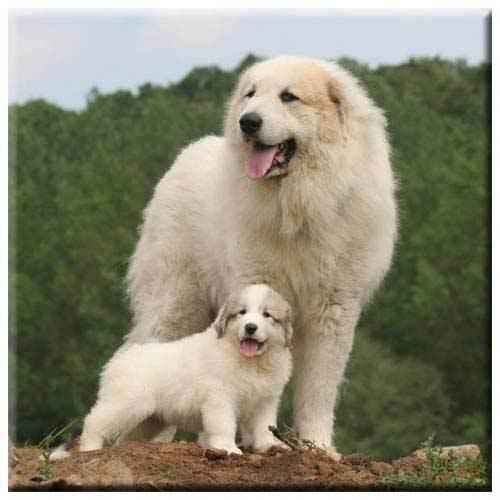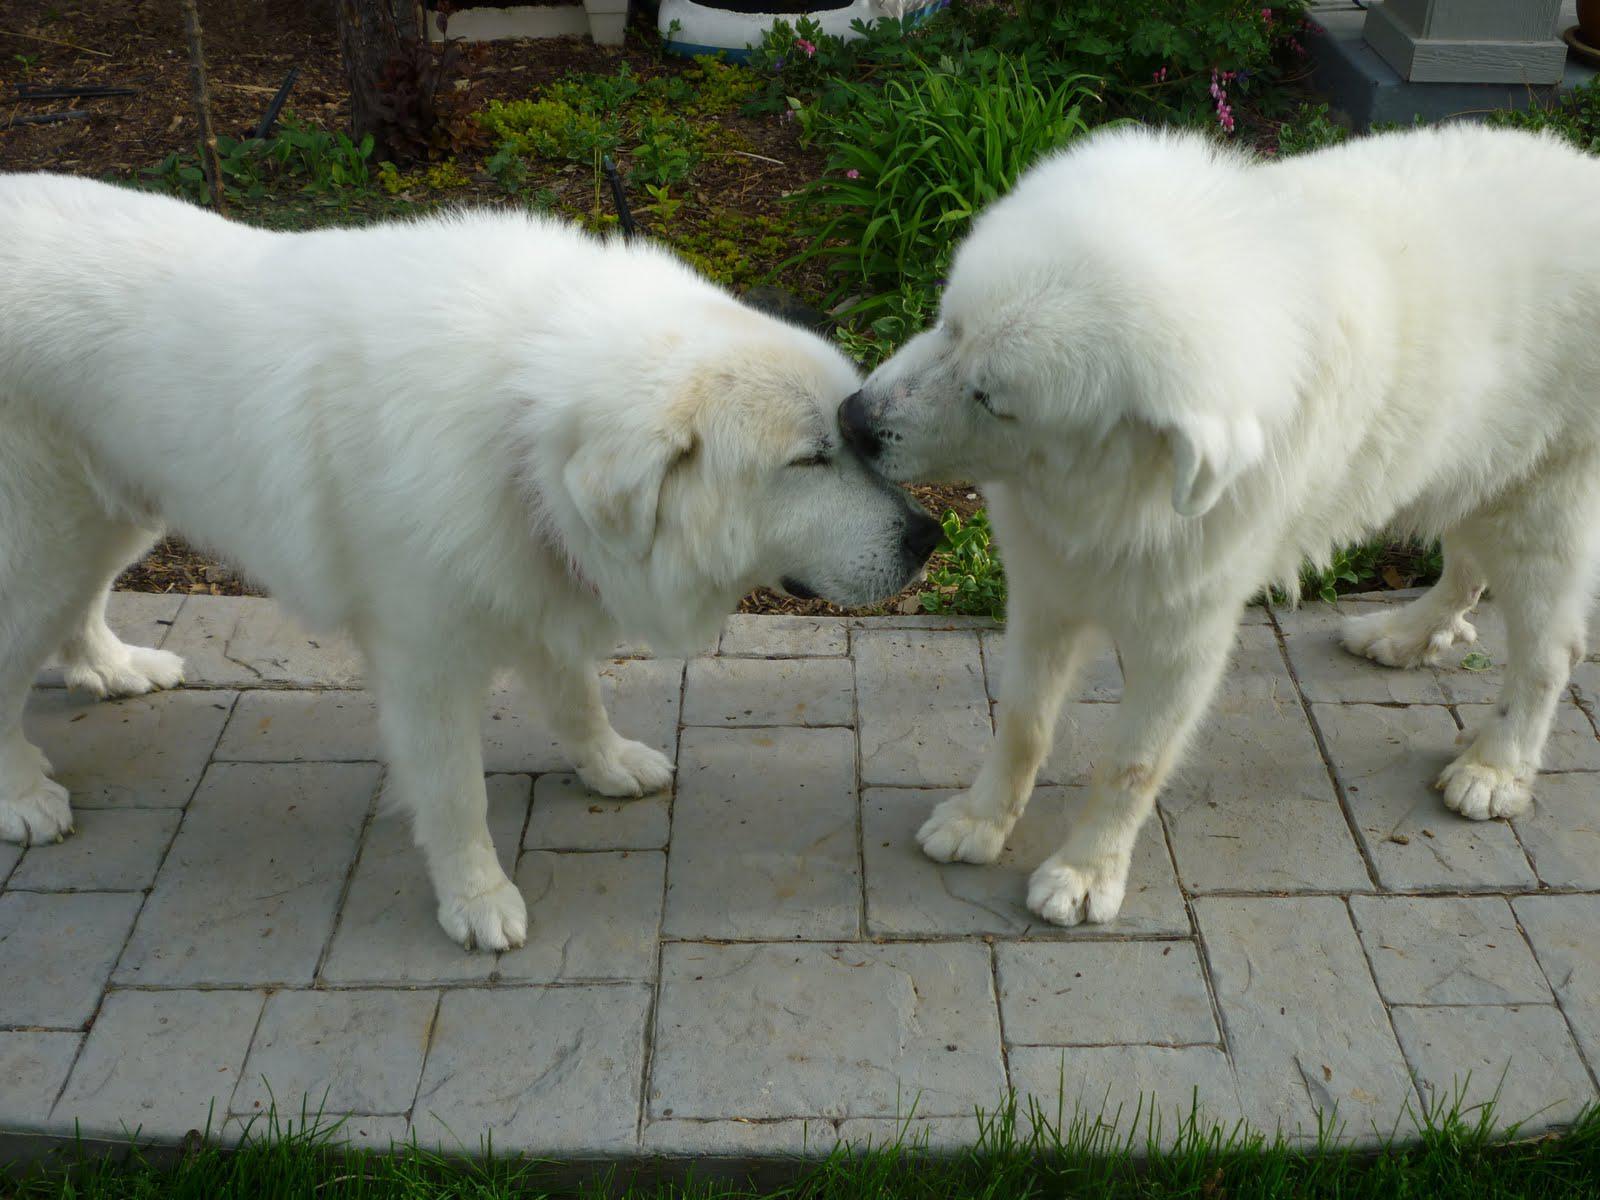The first image is the image on the left, the second image is the image on the right. For the images displayed, is the sentence "The dog in the image on the right is on green grass." factually correct? Answer yes or no. No. The first image is the image on the left, the second image is the image on the right. Considering the images on both sides, is "Right image shows exactly one white dog, which is standing on all fours on grass." valid? Answer yes or no. No. 